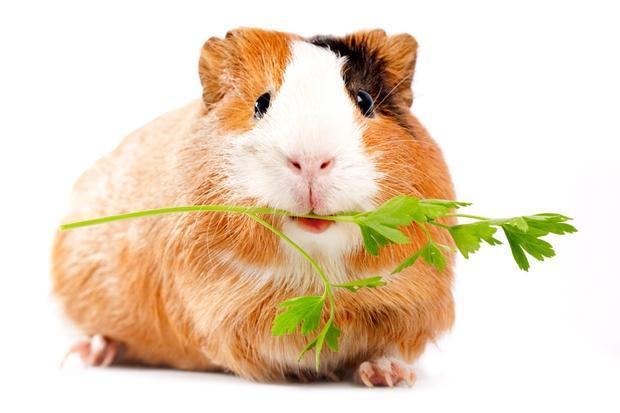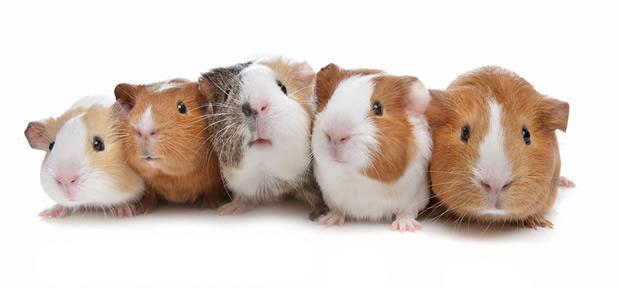The first image is the image on the left, the second image is the image on the right. For the images displayed, is the sentence "In the left image, there are two guinea pigs" factually correct? Answer yes or no. No. 